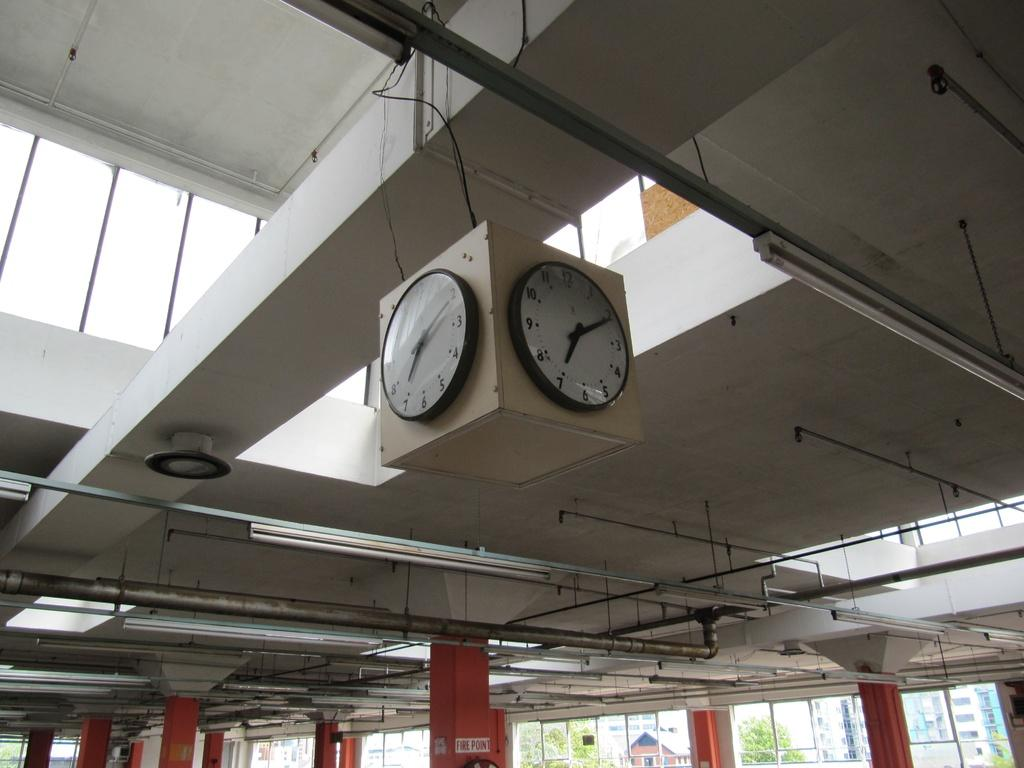<image>
Present a compact description of the photo's key features. orange column with fire point sign on it and clocks hanging down with time of 7:10 